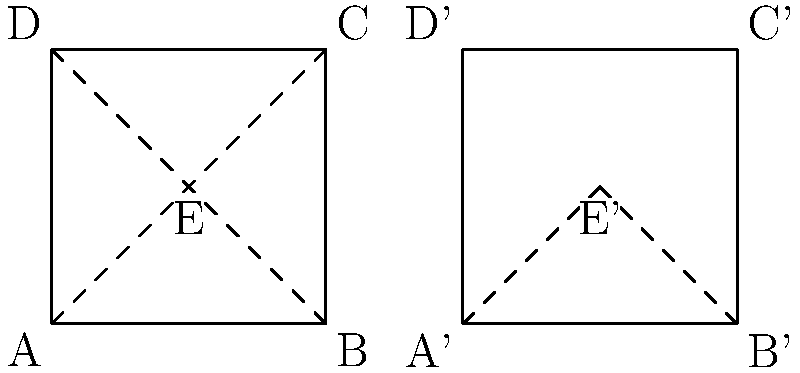When folding an origami square along its diagonal, which transformation best describes the movement of point E to E' in the resulting shape? To answer this question, let's analyze the transformation step-by-step:

1. In the original square ABCD, point E is at the center (1,1).
2. The diagonal fold is represented by the line AC.
3. When folded, triangle AEC is transformed to overlap with triangle AED.
4. This transformation involves:
   a) A reflection of point E across the line AC.
   b) A rotation of 180° around point A.
5. Both reflection and rotation are isometries (distance-preserving transformations).
6. However, the key difference is that reflection changes the orientation (chirality) of the shape, while rotation preserves it.
7. In this case, the orientation of triangle AEC is preserved when it overlaps with AED.
8. Therefore, the transformation that best describes the movement of E to E' is a rotation of 180° around point A.

This concept of rotation in origami folding is similar to how a toddler might flip a page in a picture book, which could be a relatable example for a parent volunteering with young children.
Answer: 180° rotation around point A 